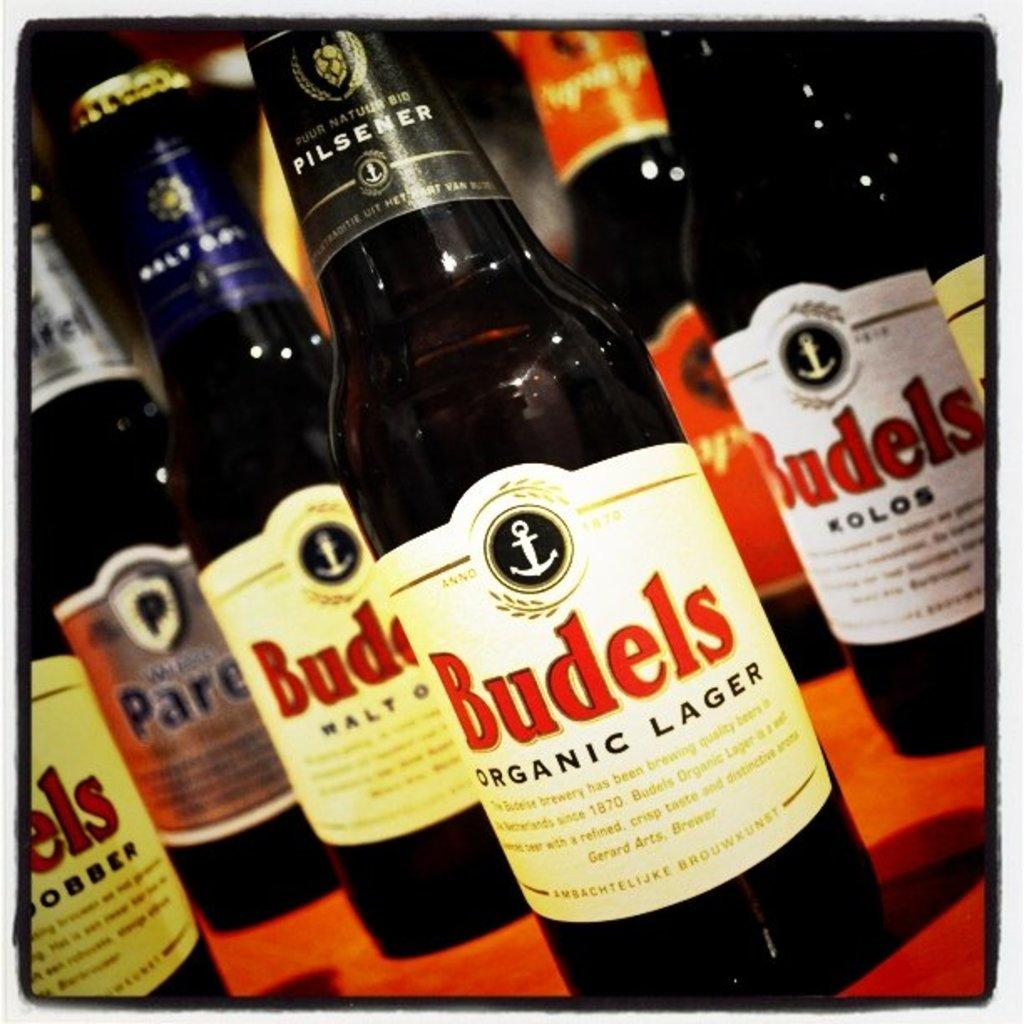<image>
Create a compact narrative representing the image presented. Several bottles of Budels Organic Lager close together. 